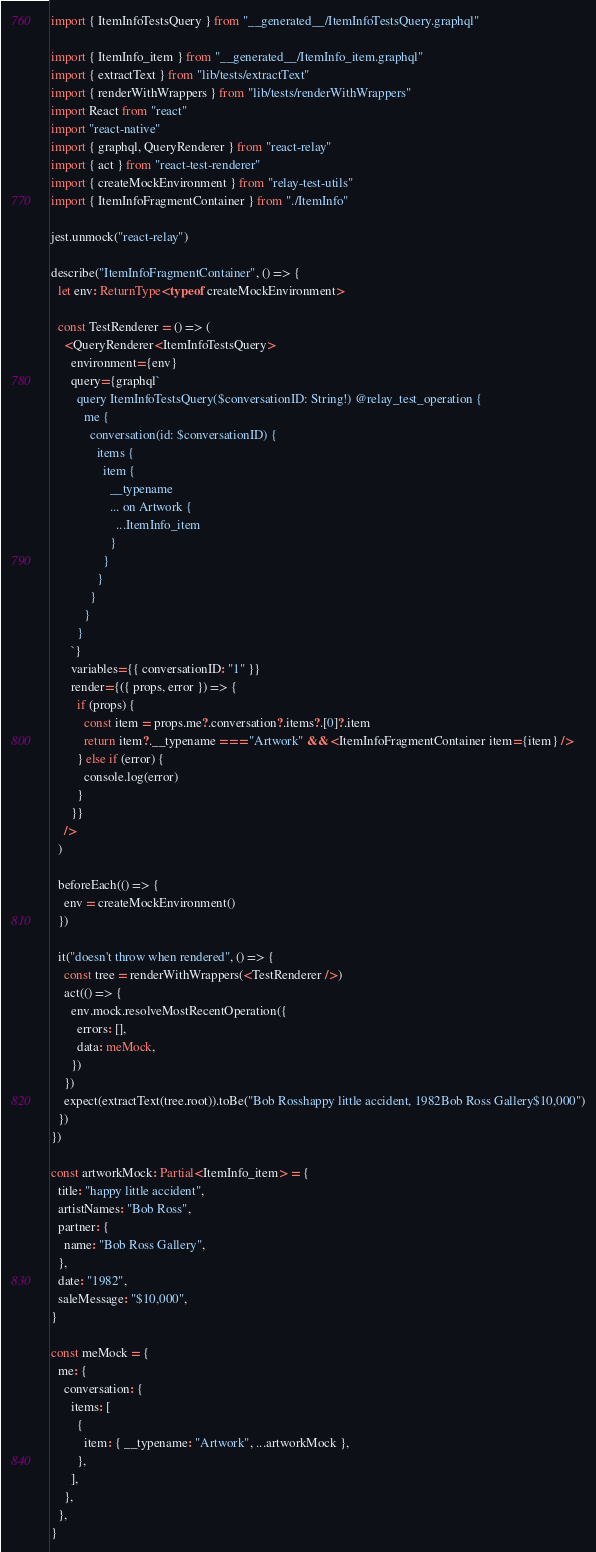<code> <loc_0><loc_0><loc_500><loc_500><_TypeScript_>import { ItemInfoTestsQuery } from "__generated__/ItemInfoTestsQuery.graphql"

import { ItemInfo_item } from "__generated__/ItemInfo_item.graphql"
import { extractText } from "lib/tests/extractText"
import { renderWithWrappers } from "lib/tests/renderWithWrappers"
import React from "react"
import "react-native"
import { graphql, QueryRenderer } from "react-relay"
import { act } from "react-test-renderer"
import { createMockEnvironment } from "relay-test-utils"
import { ItemInfoFragmentContainer } from "./ItemInfo"

jest.unmock("react-relay")

describe("ItemInfoFragmentContainer", () => {
  let env: ReturnType<typeof createMockEnvironment>

  const TestRenderer = () => (
    <QueryRenderer<ItemInfoTestsQuery>
      environment={env}
      query={graphql`
        query ItemInfoTestsQuery($conversationID: String!) @relay_test_operation {
          me {
            conversation(id: $conversationID) {
              items {
                item {
                  __typename
                  ... on Artwork {
                    ...ItemInfo_item
                  }
                }
              }
            }
          }
        }
      `}
      variables={{ conversationID: "1" }}
      render={({ props, error }) => {
        if (props) {
          const item = props.me?.conversation?.items?.[0]?.item
          return item?.__typename === "Artwork" && <ItemInfoFragmentContainer item={item} />
        } else if (error) {
          console.log(error)
        }
      }}
    />
  )

  beforeEach(() => {
    env = createMockEnvironment()
  })

  it("doesn't throw when rendered", () => {
    const tree = renderWithWrappers(<TestRenderer />)
    act(() => {
      env.mock.resolveMostRecentOperation({
        errors: [],
        data: meMock,
      })
    })
    expect(extractText(tree.root)).toBe("Bob Rosshappy little accident, 1982Bob Ross Gallery$10,000")
  })
})

const artworkMock: Partial<ItemInfo_item> = {
  title: "happy little accident",
  artistNames: "Bob Ross",
  partner: {
    name: "Bob Ross Gallery",
  },
  date: "1982",
  saleMessage: "$10,000",
}

const meMock = {
  me: {
    conversation: {
      items: [
        {
          item: { __typename: "Artwork", ...artworkMock },
        },
      ],
    },
  },
}
</code> 